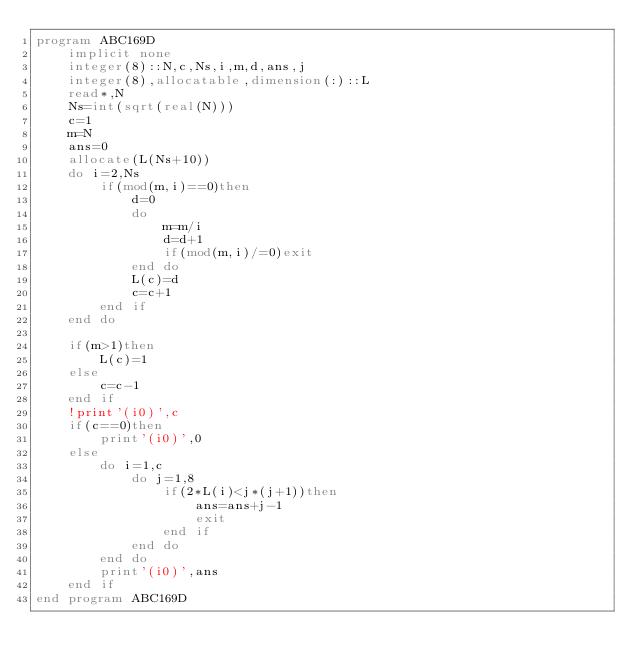<code> <loc_0><loc_0><loc_500><loc_500><_FORTRAN_>program ABC169D
    implicit none
    integer(8)::N,c,Ns,i,m,d,ans,j
    integer(8),allocatable,dimension(:)::L
    read*,N
    Ns=int(sqrt(real(N)))
    c=1
    m=N
    ans=0
    allocate(L(Ns+10))
    do i=2,Ns
        if(mod(m,i)==0)then
            d=0
            do
                m=m/i
                d=d+1
                if(mod(m,i)/=0)exit
            end do
            L(c)=d
            c=c+1
        end if
    end do

    if(m>1)then
        L(c)=1
    else
        c=c-1
    end if
    !print'(i0)',c
    if(c==0)then
        print'(i0)',0
    else
        do i=1,c
            do j=1,8
                if(2*L(i)<j*(j+1))then
                    ans=ans+j-1
                    exit
                end if
            end do
        end do
        print'(i0)',ans
    end if
end program ABC169D</code> 